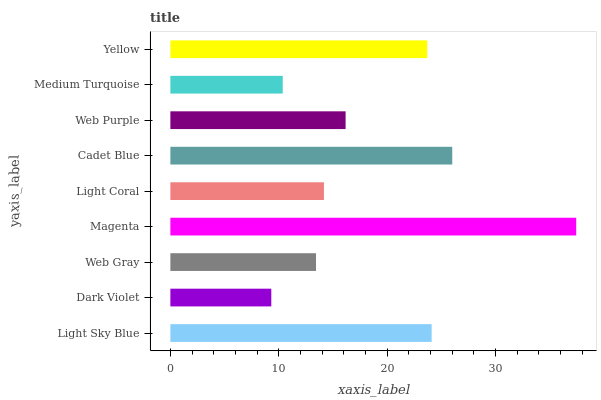Is Dark Violet the minimum?
Answer yes or no. Yes. Is Magenta the maximum?
Answer yes or no. Yes. Is Web Gray the minimum?
Answer yes or no. No. Is Web Gray the maximum?
Answer yes or no. No. Is Web Gray greater than Dark Violet?
Answer yes or no. Yes. Is Dark Violet less than Web Gray?
Answer yes or no. Yes. Is Dark Violet greater than Web Gray?
Answer yes or no. No. Is Web Gray less than Dark Violet?
Answer yes or no. No. Is Web Purple the high median?
Answer yes or no. Yes. Is Web Purple the low median?
Answer yes or no. Yes. Is Light Coral the high median?
Answer yes or no. No. Is Web Gray the low median?
Answer yes or no. No. 